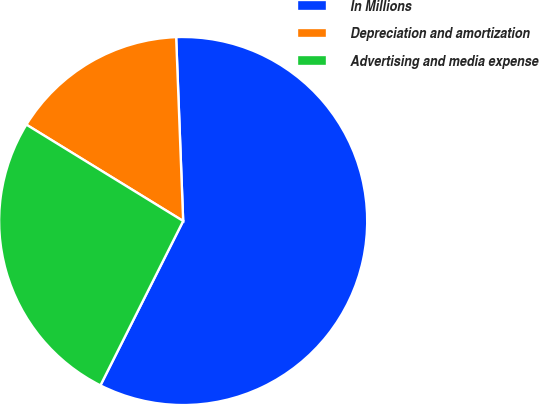Convert chart. <chart><loc_0><loc_0><loc_500><loc_500><pie_chart><fcel>In Millions<fcel>Depreciation and amortization<fcel>Advertising and media expense<nl><fcel>58.03%<fcel>15.62%<fcel>26.35%<nl></chart> 